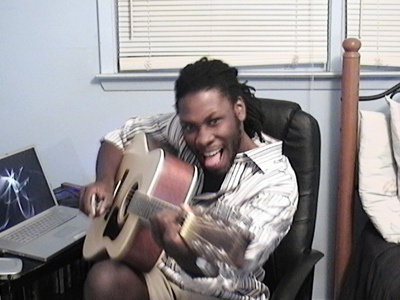Describe the objects in this image and their specific colors. I can see people in lightgray, black, gray, darkgray, and white tones, bed in lightgray, black, darkgray, and gray tones, chair in lightgray, black, gray, and darkgray tones, laptop in lightgray, gray, and black tones, and cell phone in lightgray, darkgray, and gray tones in this image. 